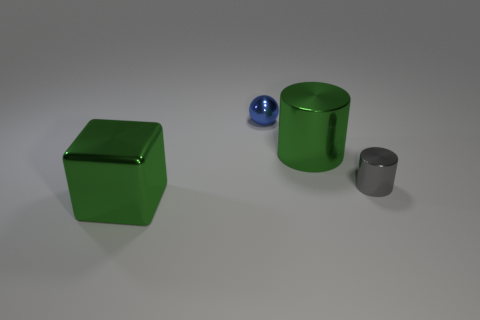There is a metal cylinder that is the same color as the cube; what is its size?
Provide a succinct answer. Large. What number of other objects are there of the same shape as the tiny blue metal object?
Give a very brief answer. 0. There is a object that is in front of the small metallic thing in front of the big object on the right side of the blue sphere; what is its color?
Ensure brevity in your answer.  Green. Does the big green metal thing that is right of the blue thing have the same shape as the tiny gray metallic thing?
Offer a terse response. Yes. How many tiny things are there?
Give a very brief answer. 2. How many blue cubes have the same size as the gray metallic cylinder?
Give a very brief answer. 0. What material is the gray object?
Provide a short and direct response. Metal. Do the big cube and the big thing behind the green block have the same color?
Provide a succinct answer. Yes. There is a object that is both behind the small gray thing and right of the blue metal ball; how big is it?
Make the answer very short. Large. There is a small blue thing that is made of the same material as the cube; what shape is it?
Provide a succinct answer. Sphere. 